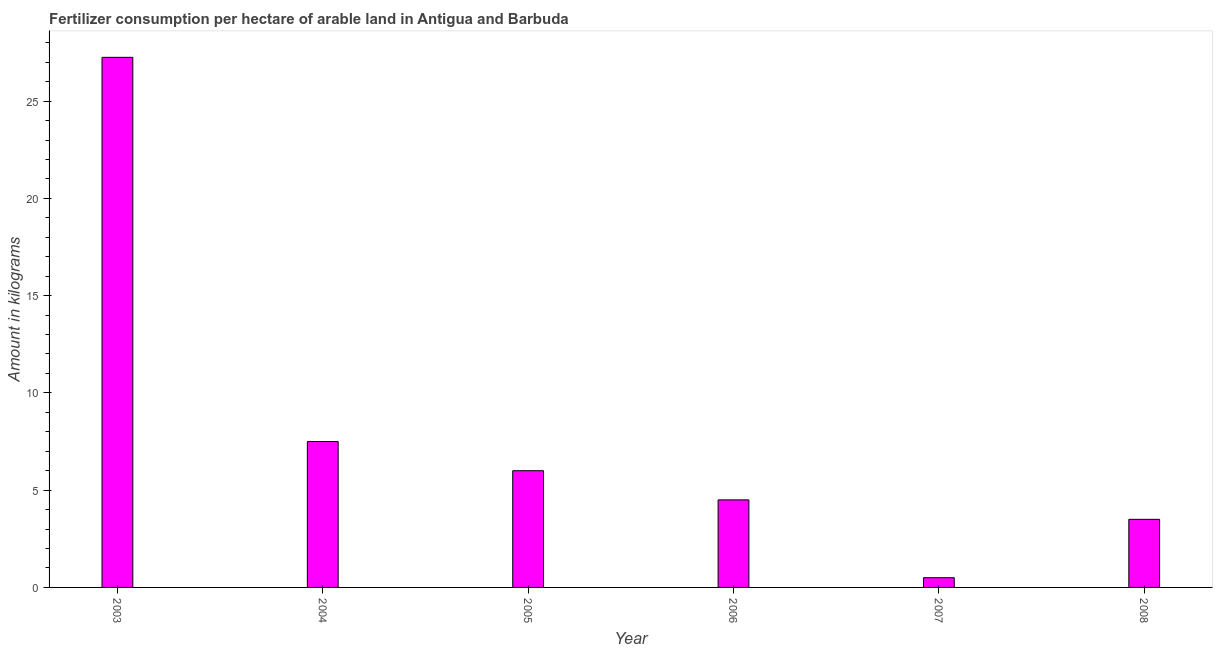What is the title of the graph?
Your answer should be very brief. Fertilizer consumption per hectare of arable land in Antigua and Barbuda . What is the label or title of the Y-axis?
Give a very brief answer. Amount in kilograms. Across all years, what is the maximum amount of fertilizer consumption?
Offer a terse response. 27.25. Across all years, what is the minimum amount of fertilizer consumption?
Offer a very short reply. 0.5. In which year was the amount of fertilizer consumption maximum?
Ensure brevity in your answer.  2003. In which year was the amount of fertilizer consumption minimum?
Offer a terse response. 2007. What is the sum of the amount of fertilizer consumption?
Your answer should be very brief. 49.25. What is the difference between the amount of fertilizer consumption in 2004 and 2005?
Offer a terse response. 1.5. What is the average amount of fertilizer consumption per year?
Ensure brevity in your answer.  8.21. What is the median amount of fertilizer consumption?
Ensure brevity in your answer.  5.25. Do a majority of the years between 2008 and 2004 (inclusive) have amount of fertilizer consumption greater than 12 kg?
Provide a short and direct response. Yes. What is the ratio of the amount of fertilizer consumption in 2004 to that in 2005?
Provide a short and direct response. 1.25. Is the amount of fertilizer consumption in 2005 less than that in 2007?
Make the answer very short. No. What is the difference between the highest and the second highest amount of fertilizer consumption?
Offer a terse response. 19.75. Is the sum of the amount of fertilizer consumption in 2003 and 2007 greater than the maximum amount of fertilizer consumption across all years?
Your response must be concise. Yes. What is the difference between the highest and the lowest amount of fertilizer consumption?
Provide a short and direct response. 26.75. How many years are there in the graph?
Provide a succinct answer. 6. Are the values on the major ticks of Y-axis written in scientific E-notation?
Offer a very short reply. No. What is the Amount in kilograms of 2003?
Ensure brevity in your answer.  27.25. What is the Amount in kilograms in 2005?
Offer a very short reply. 6. What is the Amount in kilograms in 2006?
Your answer should be very brief. 4.5. What is the difference between the Amount in kilograms in 2003 and 2004?
Keep it short and to the point. 19.75. What is the difference between the Amount in kilograms in 2003 and 2005?
Offer a terse response. 21.25. What is the difference between the Amount in kilograms in 2003 and 2006?
Ensure brevity in your answer.  22.75. What is the difference between the Amount in kilograms in 2003 and 2007?
Keep it short and to the point. 26.75. What is the difference between the Amount in kilograms in 2003 and 2008?
Ensure brevity in your answer.  23.75. What is the difference between the Amount in kilograms in 2004 and 2006?
Keep it short and to the point. 3. What is the difference between the Amount in kilograms in 2004 and 2007?
Offer a terse response. 7. What is the difference between the Amount in kilograms in 2004 and 2008?
Provide a short and direct response. 4. What is the difference between the Amount in kilograms in 2005 and 2007?
Your response must be concise. 5.5. What is the difference between the Amount in kilograms in 2006 and 2008?
Keep it short and to the point. 1. What is the difference between the Amount in kilograms in 2007 and 2008?
Your answer should be compact. -3. What is the ratio of the Amount in kilograms in 2003 to that in 2004?
Ensure brevity in your answer.  3.63. What is the ratio of the Amount in kilograms in 2003 to that in 2005?
Your answer should be compact. 4.54. What is the ratio of the Amount in kilograms in 2003 to that in 2006?
Provide a succinct answer. 6.06. What is the ratio of the Amount in kilograms in 2003 to that in 2007?
Give a very brief answer. 54.5. What is the ratio of the Amount in kilograms in 2003 to that in 2008?
Your answer should be compact. 7.79. What is the ratio of the Amount in kilograms in 2004 to that in 2006?
Your answer should be very brief. 1.67. What is the ratio of the Amount in kilograms in 2004 to that in 2008?
Offer a terse response. 2.14. What is the ratio of the Amount in kilograms in 2005 to that in 2006?
Give a very brief answer. 1.33. What is the ratio of the Amount in kilograms in 2005 to that in 2007?
Provide a succinct answer. 12. What is the ratio of the Amount in kilograms in 2005 to that in 2008?
Provide a short and direct response. 1.71. What is the ratio of the Amount in kilograms in 2006 to that in 2007?
Your response must be concise. 9. What is the ratio of the Amount in kilograms in 2006 to that in 2008?
Your answer should be compact. 1.29. What is the ratio of the Amount in kilograms in 2007 to that in 2008?
Provide a succinct answer. 0.14. 